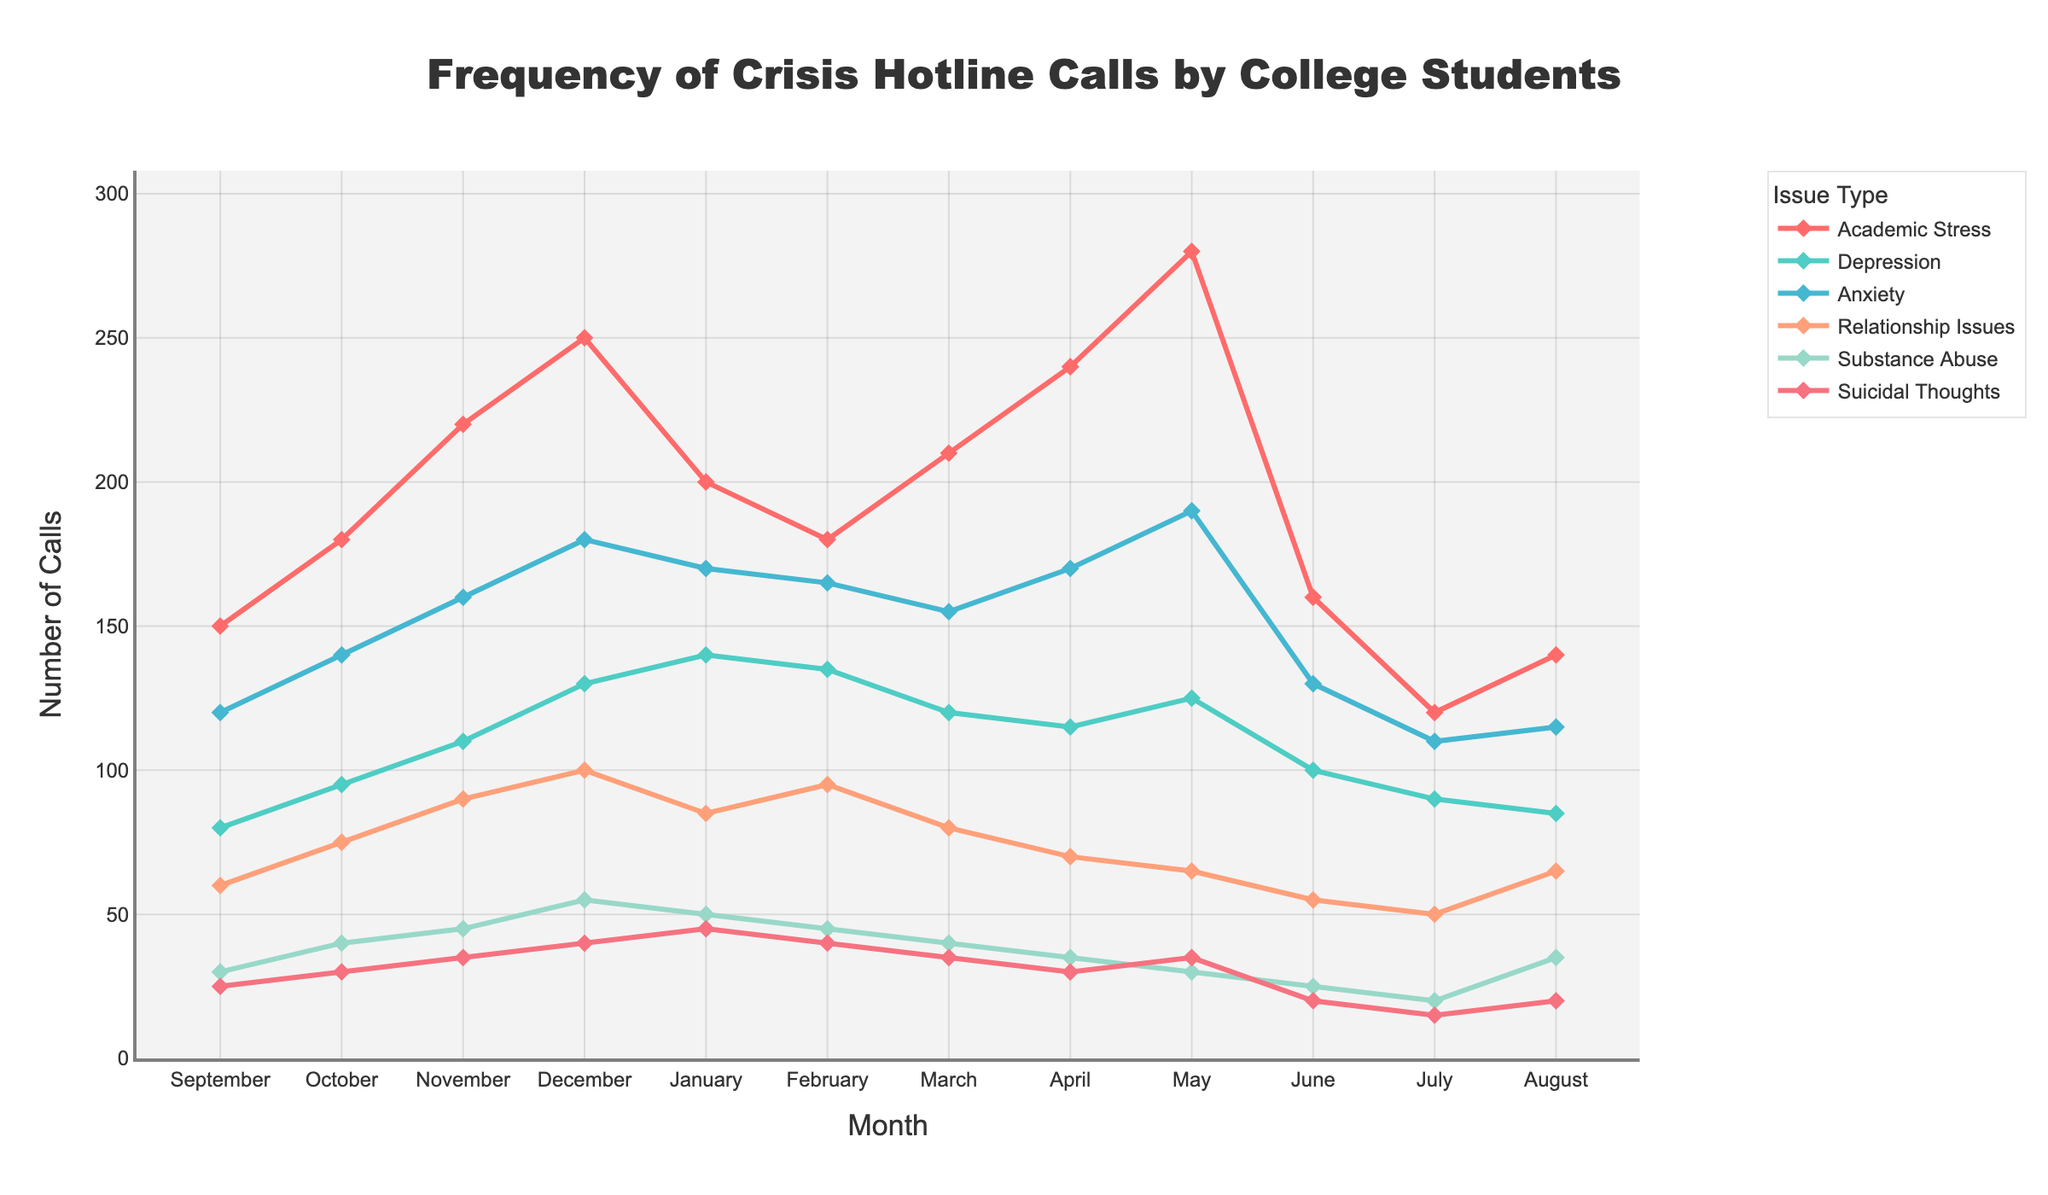What month had the highest number of calls for academic stress? From the line representing academic stress, the peak point is in May. Therefore, analyzing the graph shows that May had the highest number of calls related to academic stress.
Answer: May Which issue type had the steadiest call frequency throughout the year? Observing all the lines, the monthly fluctuations in the number of calls for depression are smaller compared to other issue types, indicating a more consistent frequency.
Answer: Depression How does the number of calls for anxiety in October compare to February? Reviewing the points for anxiety: October had 140 calls, and February had 165 calls. By comparing, February had more calls than October.
Answer: February had more calls In which month is the difference between calls about suicidal thoughts and relationship issues the greatest? The widest gap between the line representing suicidal thoughts and the line representing relationship issues is seen in December. Suicidal thoughts have 40 calls, and relationship issues have 100 calls in December, making a difference of 60 calls.
Answer: December What's the average number of calls for relationship issues in the months of January, February, and March? Summing up the calls for relationship issues in these months: 85 (January) + 95 (February) + 80 (March) = 260. The average is 260 / 3 = approximately 86.7
Answer: ~86.7 Which issue type had the highest increase in calls from September to May? To determine the highest increase, compare the calls in May with September for all issues. Academic stress increased from 150 to 280 (an increase of 130), which is the largest among all.
Answer: Academic Stress What is the overall trend for calls related to substance abuse throughout the year? Observing the line for substance abuse, the number of calls increases steadily until December, slightly drops to January, remains relatively steady through spring, and decreases further till August.
Answer: Increasing then decreasing Which two issue types had nearly equal numbers of calls in the month of June? Observing the points for June, anxiety (130 calls) and depression (100 calls) are relatively close, but the closest two are substance abuse (25) and suicidal thoughts (20).
Answer: Substance Abuse and Suicidal Thoughts During which months did calls for depressive symptoms peak and then subsequently decrease steadily? Depression calls peak in January at 140 calls and then show a steady decrease for the following months.
Answer: January 